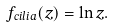Convert formula to latex. <formula><loc_0><loc_0><loc_500><loc_500>f _ { c i l i a } ( z ) = \ln z .</formula> 